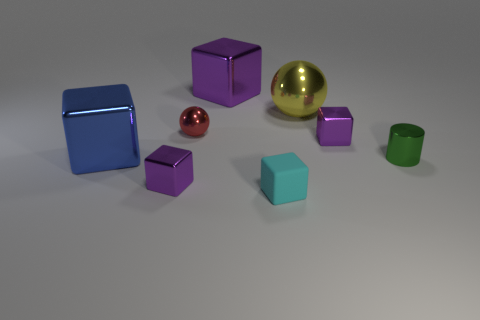Is there anything else that has the same material as the cyan block?
Your response must be concise. No. How many small things are cyan things or green cylinders?
Your answer should be compact. 2. The cyan thing that is the same shape as the blue shiny thing is what size?
Give a very brief answer. Small. What is the material of the big cube behind the tiny cube behind the cylinder?
Your response must be concise. Metal. How many shiny things are blue spheres or small green cylinders?
Your answer should be very brief. 1. What is the color of the other shiny thing that is the same shape as the red thing?
Provide a succinct answer. Yellow. How many matte blocks have the same color as the matte thing?
Your response must be concise. 0. There is a purple cube left of the red shiny thing; is there a small red metal object behind it?
Keep it short and to the point. Yes. How many small objects are both to the right of the red metal object and behind the tiny matte object?
Give a very brief answer. 2. How many purple cubes are made of the same material as the small cyan cube?
Ensure brevity in your answer.  0. 